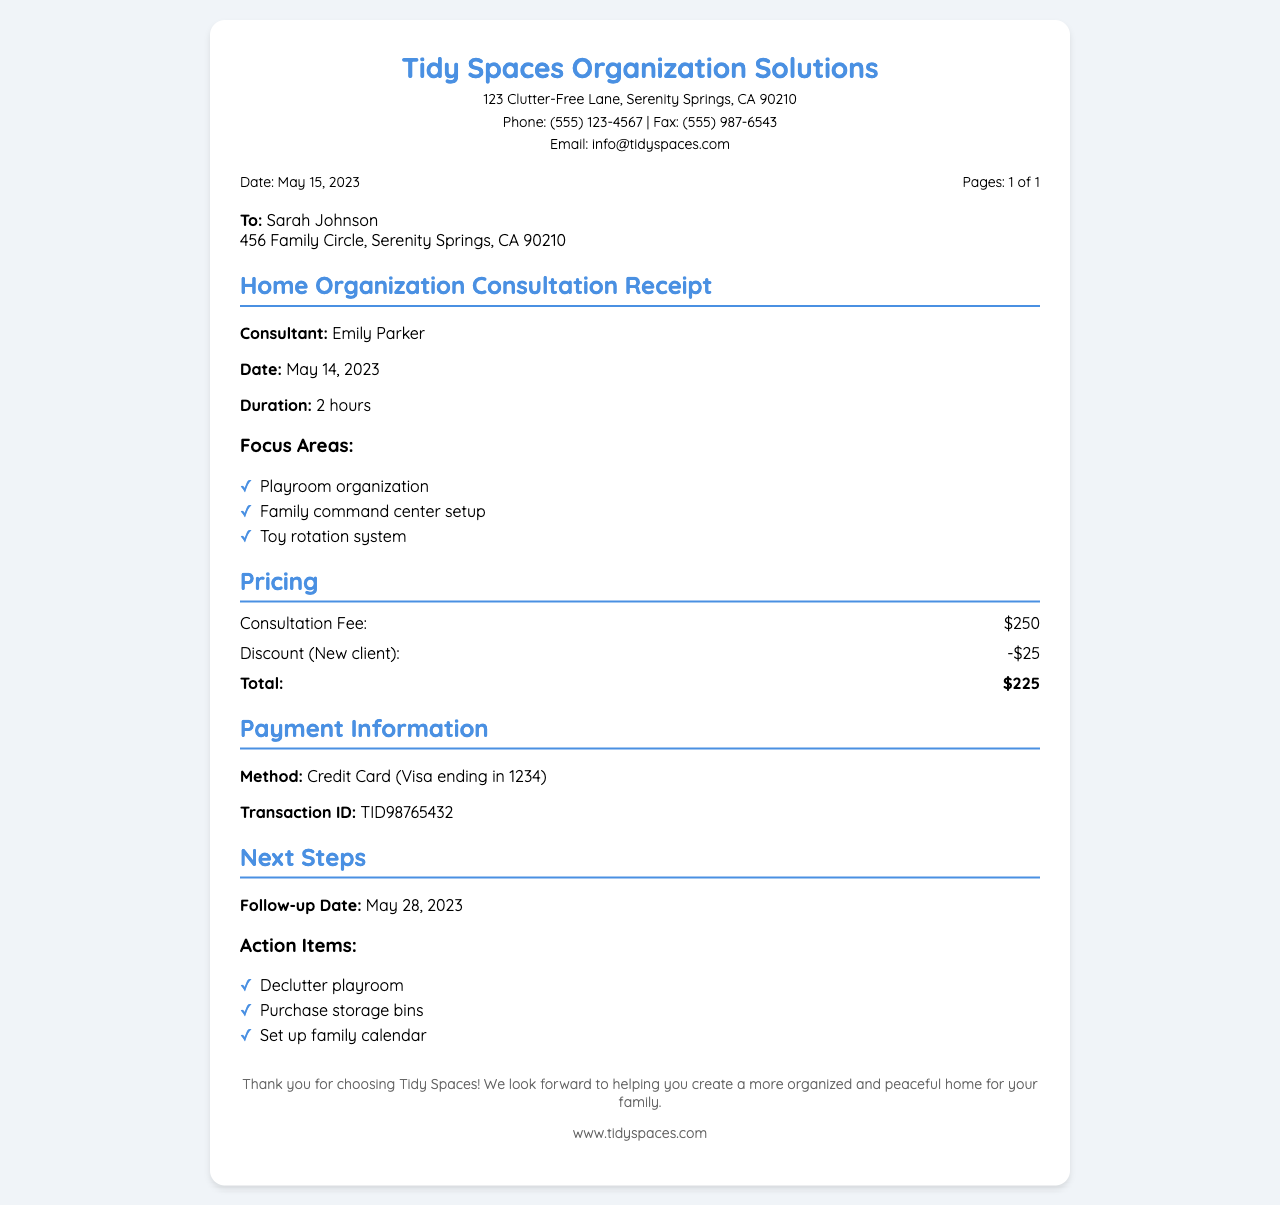What is the name of the consulting service? The document displays the name of the consulting service at the top.
Answer: Tidy Spaces Organization Solutions Who is the consultant for the home organization consultation? The consultant's name is mentioned in the receipt section about the consultation details.
Answer: Emily Parker What is the total amount charged for the consultation? The total price is calculated after applying the discount to the consultation fee.
Answer: $225 On what date was the consultation held? The date of the consultation is explicitly stated in the document.
Answer: May 14, 2023 What payment method was used for the transaction? The payment details section specifies how the transaction was completed.
Answer: Credit Card How many hours did the consultation last? The duration of the consultation is indicated in the document details.
Answer: 2 hours What are the focus areas mentioned for organization? The focus areas are listed in the consultation details section under 'Focus Areas'.
Answer: Playroom organization, Family command center setup, Toy rotation system What was the discount amount for being a new client? The discount applied is referenced in the pricing section of the document.
Answer: -$25 When is the follow-up date scheduled? The follow-up date is outlined in the 'Next Steps' section of the document.
Answer: May 28, 2023 